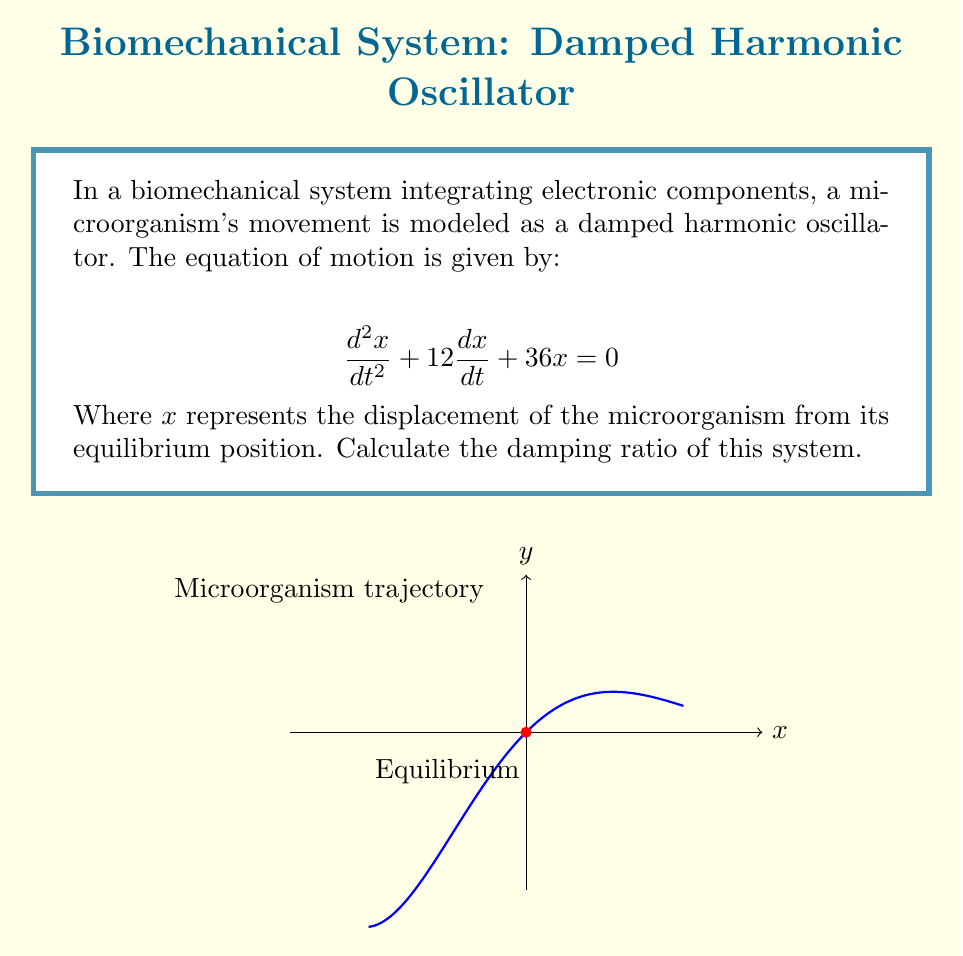Could you help me with this problem? To calculate the damping ratio, we need to follow these steps:

1) The general form of a second-order linear differential equation for a damped harmonic oscillator is:

   $$\frac{d^2x}{dt^2} + 2\zeta\omega_n\frac{dx}{dt} + \omega_n^2x = 0$$

   Where $\zeta$ is the damping ratio and $\omega_n$ is the natural frequency.

2) Comparing our given equation with the general form:

   $$\frac{d^2x}{dt^2} + 12\frac{dx}{dt} + 36x = 0$$

   We can identify that:
   
   $2\zeta\omega_n = 12$
   $\omega_n^2 = 36$

3) From $\omega_n^2 = 36$, we can calculate $\omega_n$:

   $$\omega_n = \sqrt{36} = 6 \text{ rad/s}$$

4) Now we can substitute this into the equation for the damping coefficient:

   $$2\zeta(6) = 12$$

5) Solving for $\zeta$:

   $$\zeta = \frac{12}{2(6)} = \frac{12}{12} = 1$$

Thus, the damping ratio of the system is 1.
Answer: $\zeta = 1$ 